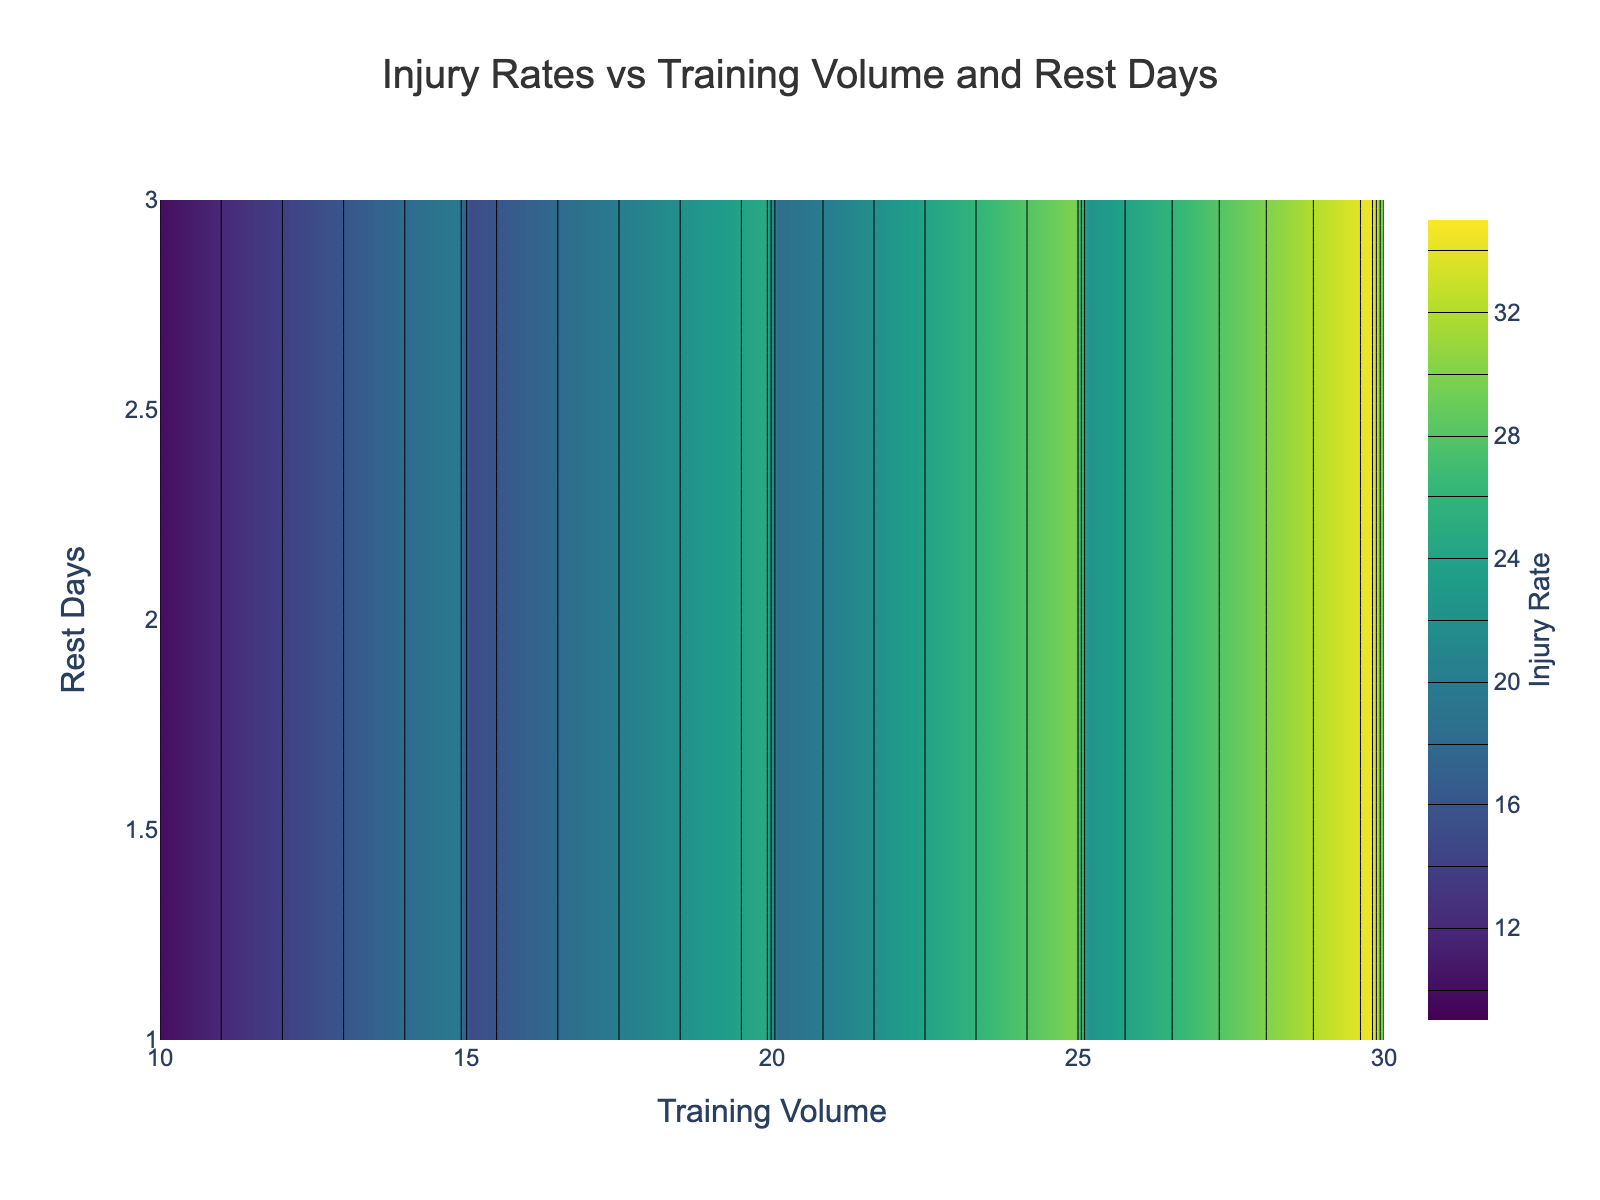What is the title of the figure? The title is placed at the top center of the figure and reads "Injury Rates vs Training Volume and Rest Days."
Answer: Injury Rates vs Training Volume and Rest Days What is the color scale used in the contour plot? The colors in the contour plot transition from dark to light shades of green, yellow, and blue, which are typical of the Viridis color scale.
Answer: Viridis On which axis is the Training Volume plotted? The x-axis shows the label "Training Volume" and has values ranging from 10 to 30.
Answer: x-axis What is the highest injury rate depicted in the figure? The highest contour level indicated is 35, which represents the highest injury rate in the plot.
Answer: 35 At what Training Volume and Rest Days configuration does the injury rate seem lowest? From the contour plot, the injury rate appears lowest where Training Volume is around 10 and Rest Days are around 3.
Answer: Training Volume 10, Rest Days 3 How does the injury rate change as Training Volume increases from 10 to 30 while keeping Rest Days constant at 1? Observing the contour lines for Rest Days equal to 1, the injury rate starts at 15 and increases progressively to 35 as Training Volume goes from 10 to 30.
Answer: Increases Does increasing Rest Days from 1 to 3 while maintaining Training Volume at 20 reduce the injury rate? Following the contour lines, with Training Volume at 20, the injury rate decreases from 25 for 1 Rest Day to 18 for 3 Rest Days.
Answer: Yes What Training Volume range shows the steepest increase in injury rate from 10 to 30 Rest Days? This specific combination isn’t entirely represented, but generally, the contour lines suggest a steeper increase in injury rates between Training Volume 25 to 30.
Answer: 25 to 30 Which scenario shows a more drastic change in injury rate: increasing Training Volume from 10 to 30 at 1 Rest Day, or increasing Rest Days from 1 to 3 at Training Volume 25? Increasing Training Volume from 10 to 30 at 1 Rest Day changes the injury rate from 15 to 35 (a difference of 20), while increasing Rest Days from 1 to 3 at Training Volume 25 changes it from 30 to 22 (a difference of 8). Thus, the former scenario shows a more drastic change.
Answer: Increasing Training Volume from 10 to 30 at 1 Rest Day 